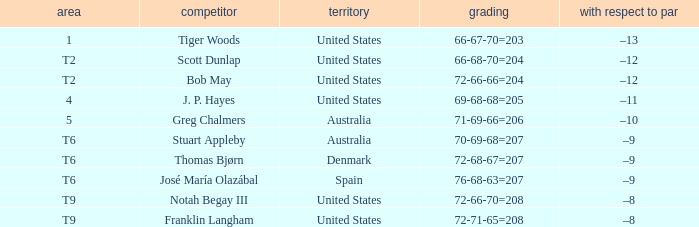What is the country of the player with a t6 place? Australia, Denmark, Spain. 